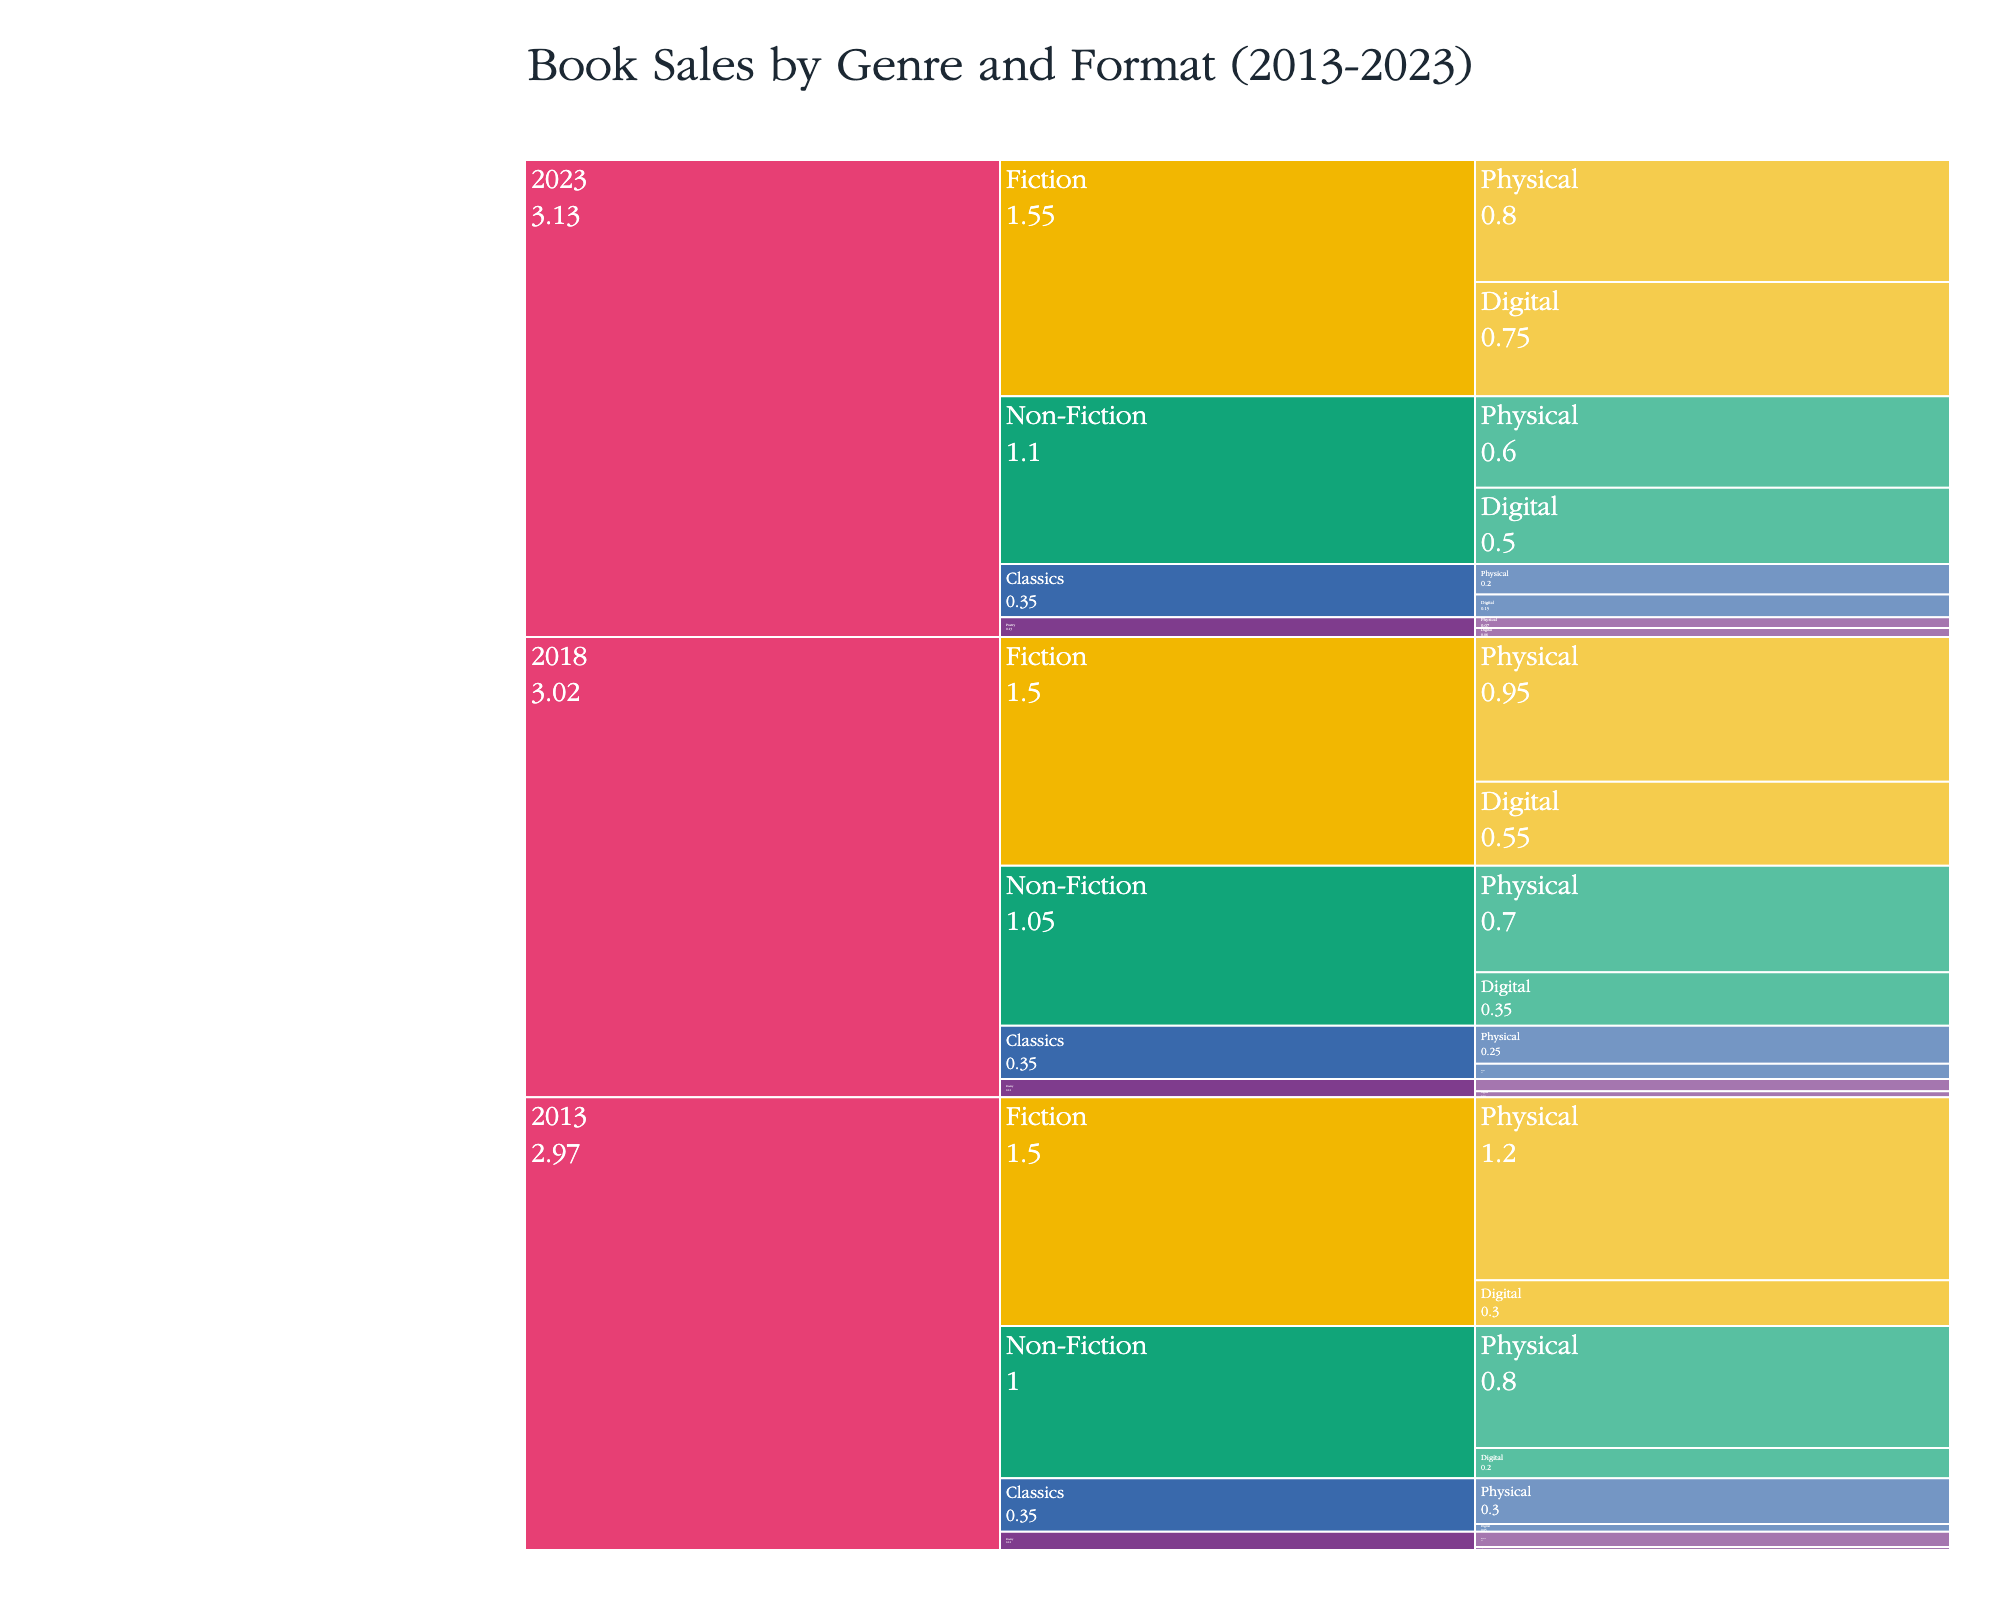What is the title of the figure? The title can be found at the top of the figure and provides an overview of the chart's content.
Answer: "Book Sales by Genre and Format (2013-2023)" Which genre shows the highest sales for digital format in 2023? To find the highest sales for digital formats in 2023, look at the digital segments for each genre in 2023 and identify the one with the largest value.
Answer: Fiction How do physical book sales for Non-Fiction in 2013 compare to 2023? Compare the value of sales for Non-Fiction Physical books in 2013 and 2023 by looking at those specific segments.
Answer: 2013 sales are higher What is the total sales for Poetry books in 2018 across both formats? Find the sales values for both Physical and Digital formats for Poetry in 2018 and add them together. The values are 80,000 and 40,000 respectively. Therefore, 80,000 + 40,000 = 120,000.
Answer: 120,000 Which format (physical or digital) has shown a larger increase in sales for Fiction from 2013 to 2023? Calculate the difference in sales for both physical and digital formats from 2013 to 2023. For Physical: 800,000 - 1,200,000 = -400,000 (a decrease). For Digital: 750,000 - 300,000 = 450,000 (an increase). Thus, Digital has shown a larger increase.
Answer: Digital What is the trend of sales for Classics in digital format from 2013 to 2023? Observe the sales data for Classics in digital format over the years 2013, 2018, and 2023 to identify the pattern. The sales increase from 50,000 in 2013, to 100,000 in 2018, and to 150,000 in 2023.
Answer: Increasing How do the total sales for all genres in physical format in 2023 compare to those in digital format in 2023? Sum the sales for all genres in physical format and digital format for the year 2023 separately. Physical: 800,000 (Fiction) + 600,000 (Non-Fiction) + 70,000 (Poetry) + 200,000 (Classics) = 1,670,000. Digital: 750,000 (Fiction) + 500,000 (Non-Fiction) + 60,000 (Poetry) + 150,000 (Classics) = 1,460,000. Compare the two sums.
Answer: Physical sales are higher Which year experienced the highest total book sales combined across all genres and formats? Add up the sales for each year across all genres and formats to identify the year with the highest total. For 2013: 1,200,000 (Fiction Physical) + 300,000 (Fiction Digital) + 800,000 (Non-Fiction Physical) + 200,000 (Non-Fiction Digital) + 100,000 (Poetry Physical) + 20,000 (Poetry Digital) + 300,000 (Classics Physical) + 50,000 (Classics Digital) = 2,970,000. Repeat the calculation for 2018 and 2023. 2013 has the highest value.
Answer: 2013 What is the change in total sales for Non-Fiction books in both formats from 2013 to 2023? Calculate the total sales for Non-Fiction in both formats for the years 2013 and 2023, then find the difference. For 2013: 800,000 (Physical) + 200,000 (Digital) = 1,000,000. For 2023: 600,000 (Physical) + 500,000 (Digital) = 1,100,000. The change is 1,100,000 - 1,000,000 = 100,000.
Answer: Increase of 100,000 Between Fiction and Non-Fiction genres, which has seen a greater overall shift towards digital format from 2013 to 2023? Calculate the shift towards digital for each genre by finding the change in sales for both formats from 2013 to 2023. For Fiction: Digital: 750,000 (2023) - 300,000 (2013) = 450,000, Physical: 800,000 (2023) - 1,200,000 (2013) = -400,000 (net shift of 450,000 - 400,000 = 50,000 towards digital). For Non-Fiction: Digital: 500,000 (2023) - 200,000 (2013) = 300,000, Physical: 600,000 (2023) - 800,000 (2013) = -200,000 (net shift of 300,000 - 200,000 = 100,000 towards digital). Non-Fiction has a greater shift towards digital.
Answer: Non-Fiction 